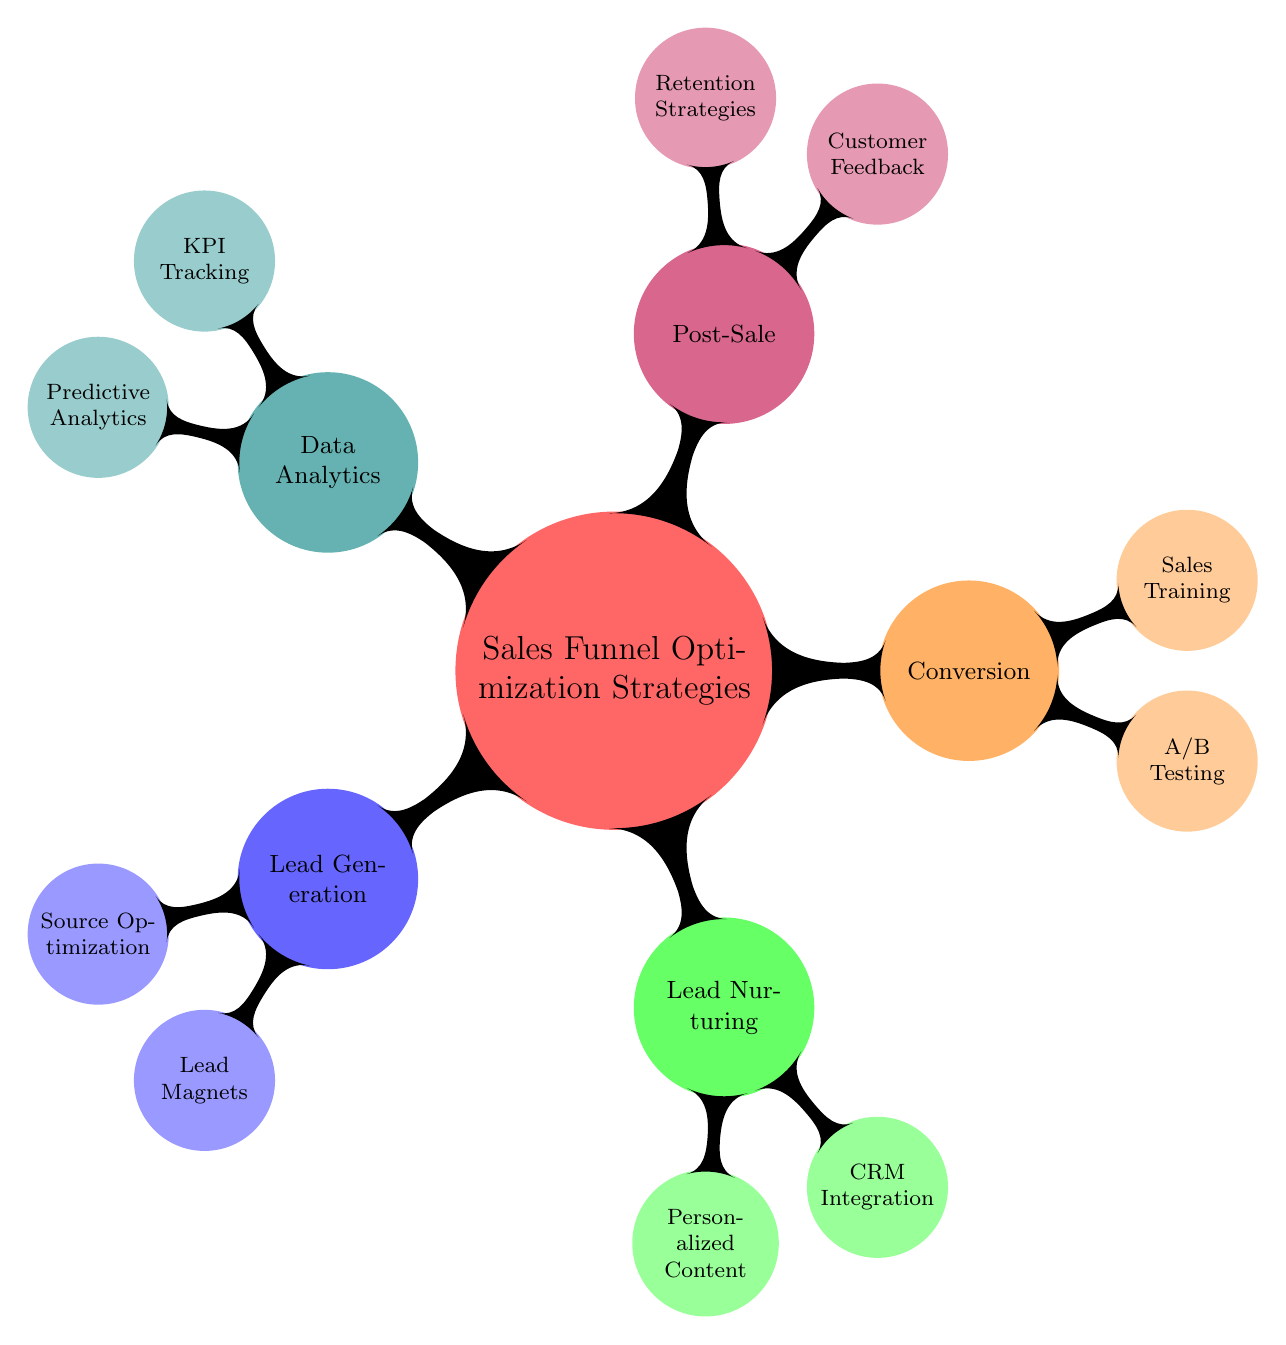What are the two main categories under "Sales Funnel Optimization Strategies"? The diagram shows five categories branching from "Sales Funnel Optimization Strategies." Among them, the two main categories displayed are "Lead Generation" and "Lead Nurturing," as they are the first two nodes underneath the main strategy node.
Answer: Lead Generation, Lead Nurturing How many strategies are listed under "Conversion"? Under the "Conversion" node, there are two strategies shown: "A/B Testing" and "Sales Training." By counting these child nodes, we determine that the total is two.
Answer: 2 What are the two types of lead magnets mentioned? The node "Lead Magnets" includes three elements, and among them, the two specified types are "Ebooks" and "Webinars." By selecting these two options, we directly answer the question based on the visual representation.
Answer: Ebooks, Webinars Which section of the diagram includes "Customer Feedback"? The term "Customer Feedback" appears under the "Post-Sale" section, as it is one of the child nodes connected to that category. By identifying its parent node, we can locate it within the mind map.
Answer: Post-Sale What is a tool mentioned under "CRM Integration"? In the "CRM Integration" category, we see the mention of "Salesforce" as one of the tools listed. Thus, identifying this specific node allows us to answer the question directly.
Answer: Salesforce What is the relationship between "KPI Tracking" and "Data Analytics"? "KPI Tracking" is a sub-node directly stemming from the "Data Analytics" node, signifying that it is part of the data analytics process utilized in sales funnel optimization. This connection describes the hierarchical relationship.
Answer: Sub-node What is one of the methods used for lead generation optimization? The mind map indicates "Social Media Campaigns" as one of the options listed under the "Source Optimization" node within "Lead Generation," representing a specific method used for enhancing lead generation.
Answer: Social Media Campaigns What are the two components of "Personalized Content"? The "Personalized Content" node breaks down into two elements: "Targeted Emails" and "Custom Landing Pages." By referring to these items, we can easily list both components.
Answer: Targeted Emails, Custom Landing Pages 